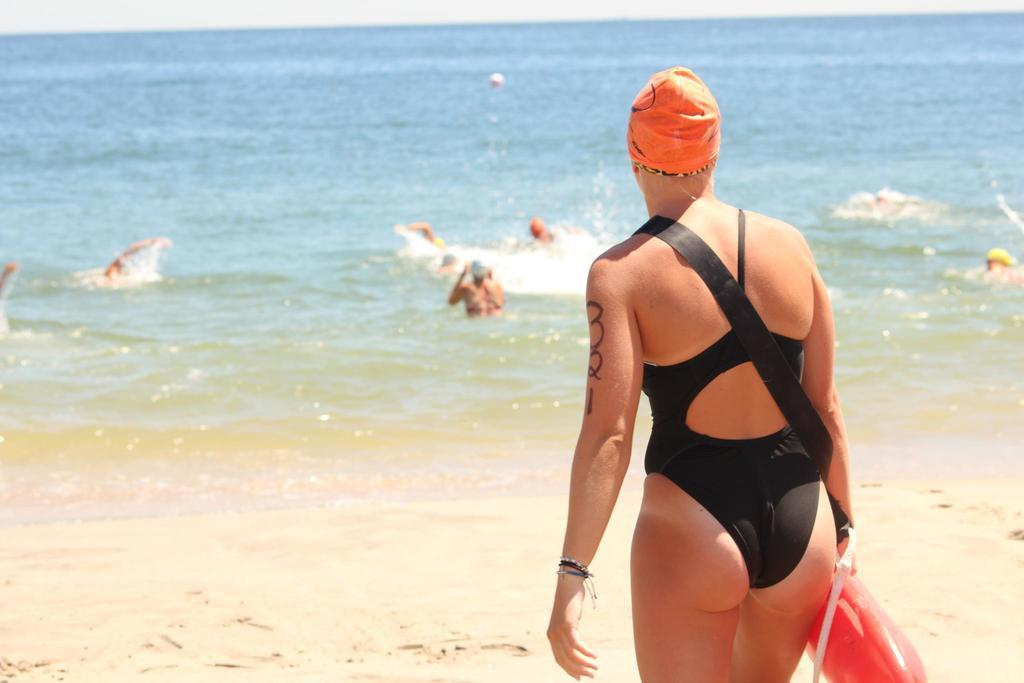Who is present in the image? There is a woman in the image. What is the woman wearing? The woman is wearing a black dress. What can be seen in the background of the image? There is a beach in the background of the image. What is visible at the bottom of the image? There is sand and water visible at the bottom of the image. Are there any other people in the image besides the woman? Yes, there are people on the beach in the background. What type of potato is being smashed on the beach in the image? There is no potato or smashing activity present in the image. 